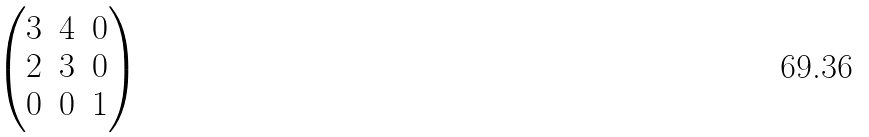Convert formula to latex. <formula><loc_0><loc_0><loc_500><loc_500>\begin{pmatrix} 3 & 4 & 0 \\ 2 & 3 & 0 \\ 0 & 0 & 1 \end{pmatrix}</formula> 